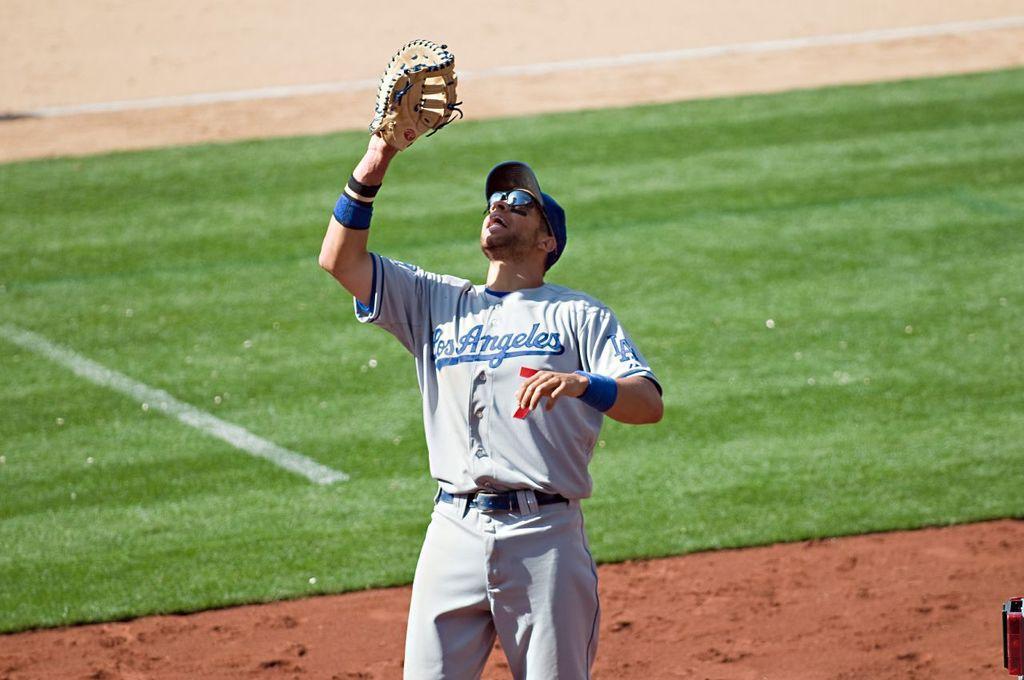In one or two sentences, can you explain what this image depicts? In this image there is a man with spectacles, hat and a baseball glove is standing, and in the background there is grass. 